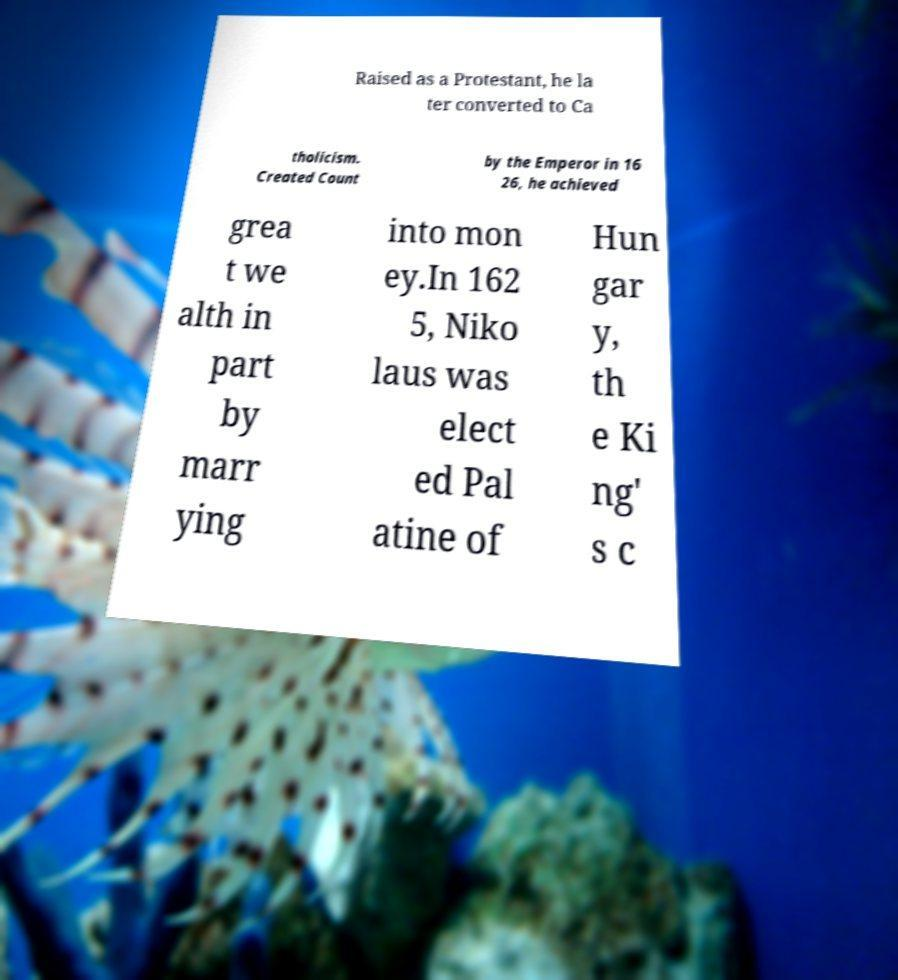Could you assist in decoding the text presented in this image and type it out clearly? Raised as a Protestant, he la ter converted to Ca tholicism. Created Count by the Emperor in 16 26, he achieved grea t we alth in part by marr ying into mon ey.In 162 5, Niko laus was elect ed Pal atine of Hun gar y, th e Ki ng' s c 